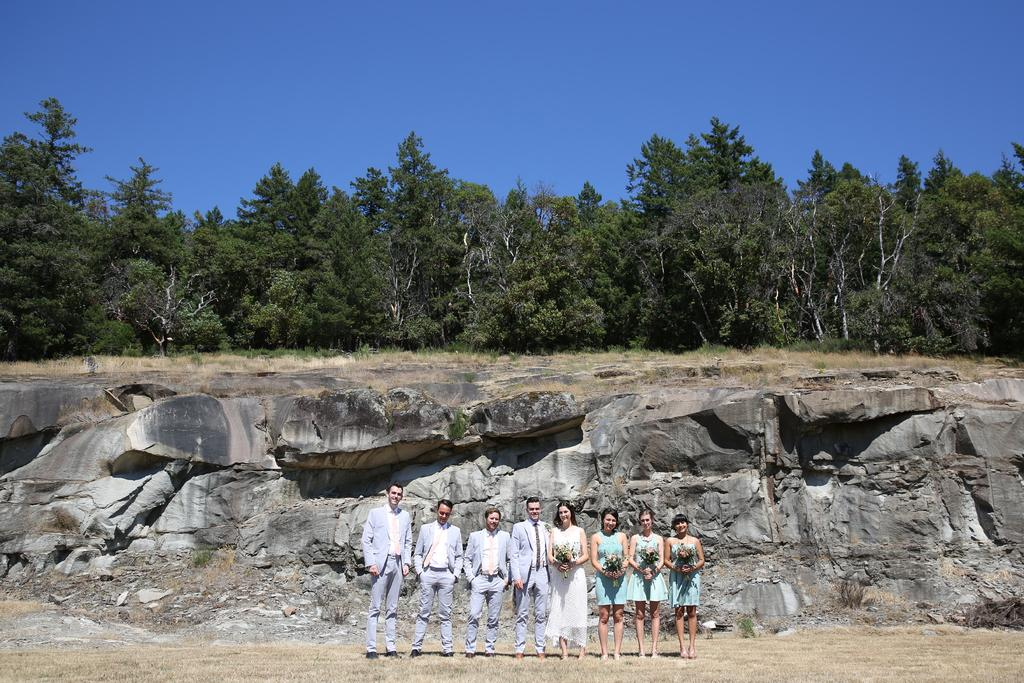What is the main subject of the image? The main subject of the image is a group of people. What are some of the people in the group holding? Some people in the group are holding bouquets. What can be seen in the background of the image? There are rocks and trees visible in the background of the image. How many houses are visible in the image? There are no houses visible in the image; it features a group of people with rocks and trees in the background. Are there any spiders crawling on the bouquets in the image? There is no indication of spiders or any other creatures present in the image. 